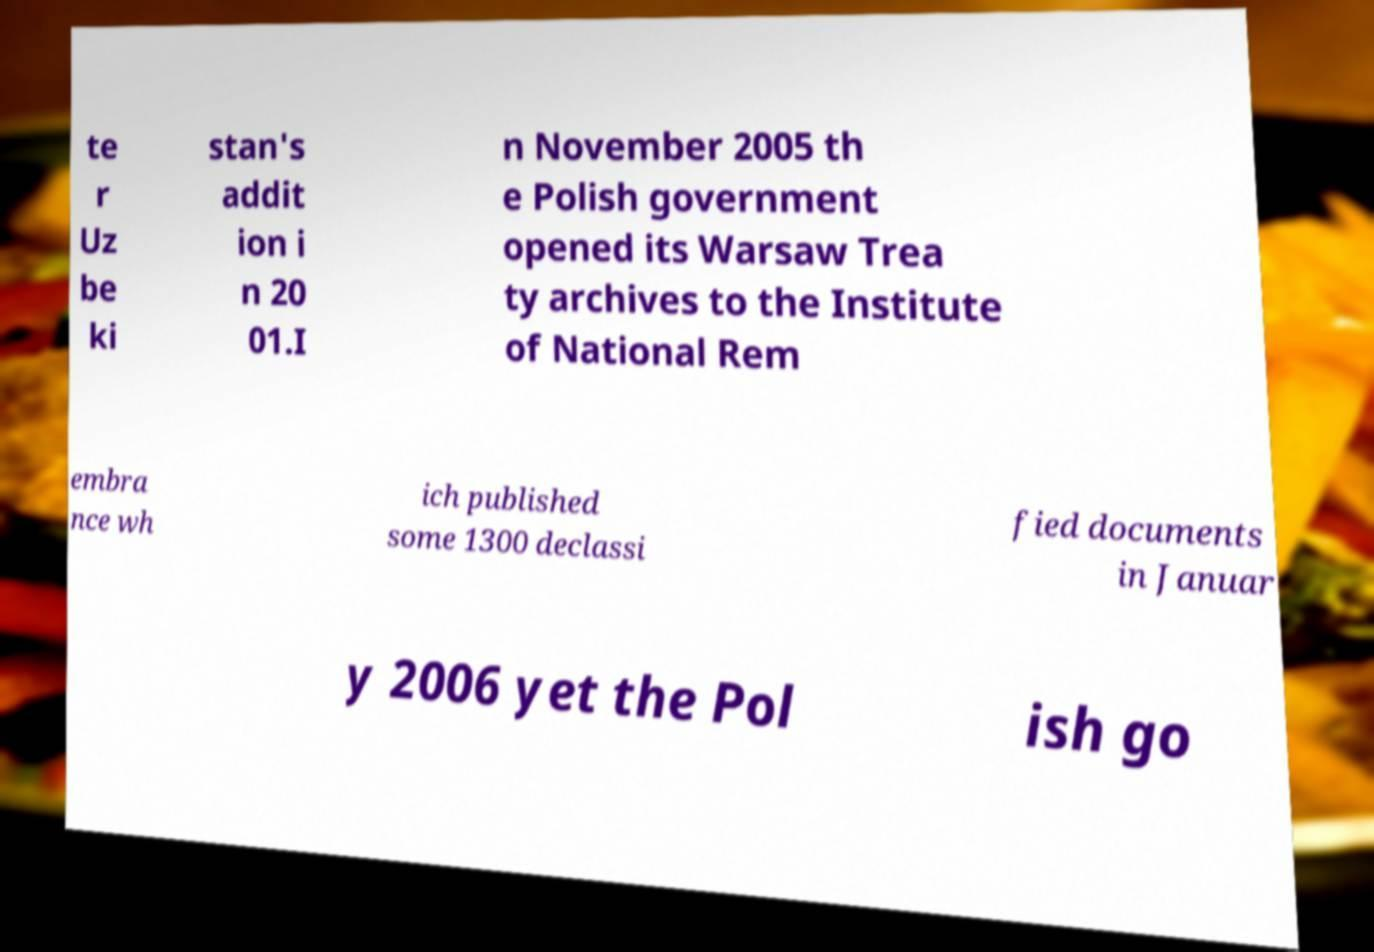What messages or text are displayed in this image? I need them in a readable, typed format. te r Uz be ki stan's addit ion i n 20 01.I n November 2005 th e Polish government opened its Warsaw Trea ty archives to the Institute of National Rem embra nce wh ich published some 1300 declassi fied documents in Januar y 2006 yet the Pol ish go 